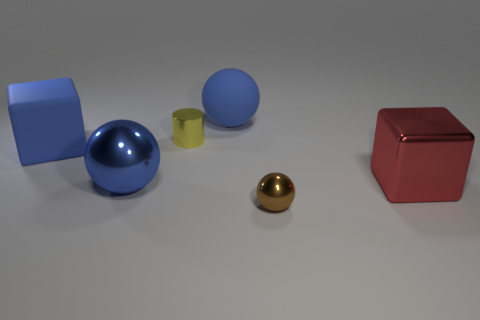Does the rubber sphere have the same color as the large metal ball?
Give a very brief answer. Yes. The blue shiny thing that is the same size as the red cube is what shape?
Your answer should be compact. Sphere. How many other objects are the same color as the large rubber sphere?
Provide a succinct answer. 2. Do the big metallic object that is on the left side of the brown sphere and the small thing in front of the big red metal block have the same shape?
Offer a terse response. Yes. How many things are large metal things that are on the right side of the yellow thing or tiny brown spheres in front of the blue metallic sphere?
Provide a succinct answer. 2. What number of other things are made of the same material as the big red cube?
Keep it short and to the point. 3. Is the material of the large blue block behind the small brown metallic ball the same as the yellow object?
Ensure brevity in your answer.  No. Is the number of red shiny objects to the left of the brown metal sphere greater than the number of big red shiny objects in front of the metal cube?
Keep it short and to the point. No. How many objects are either metal things that are to the left of the tiny brown ball or large things?
Give a very brief answer. 5. There is a red thing that is made of the same material as the yellow thing; what shape is it?
Give a very brief answer. Cube. 